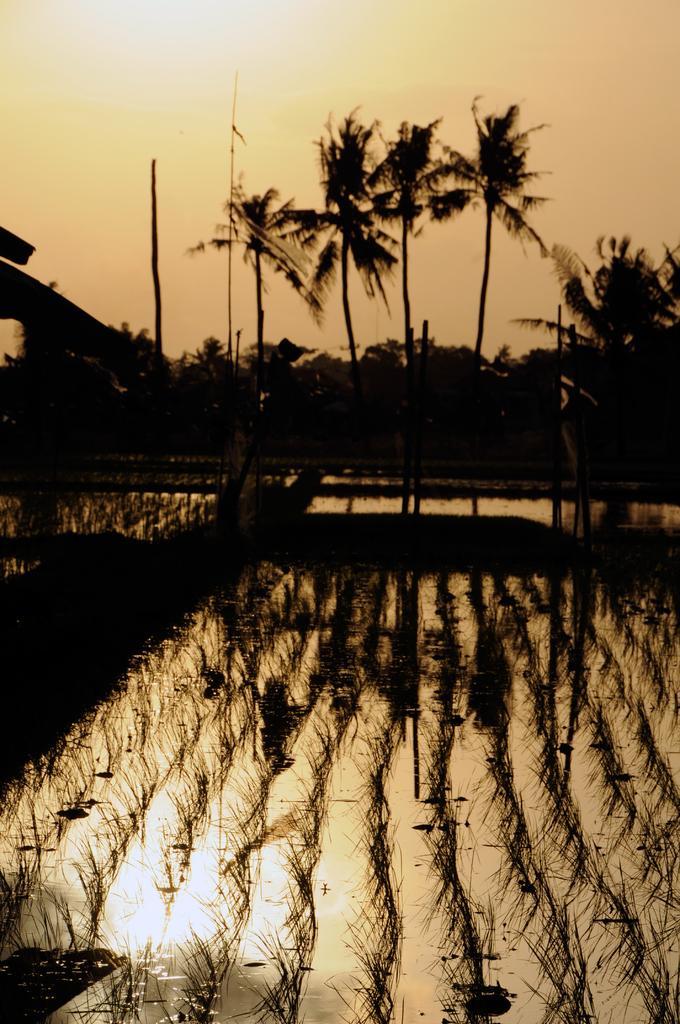In one or two sentences, can you explain what this image depicts? In this image we can see water, group of plants. In the background, we can see group of trees and the sky. 